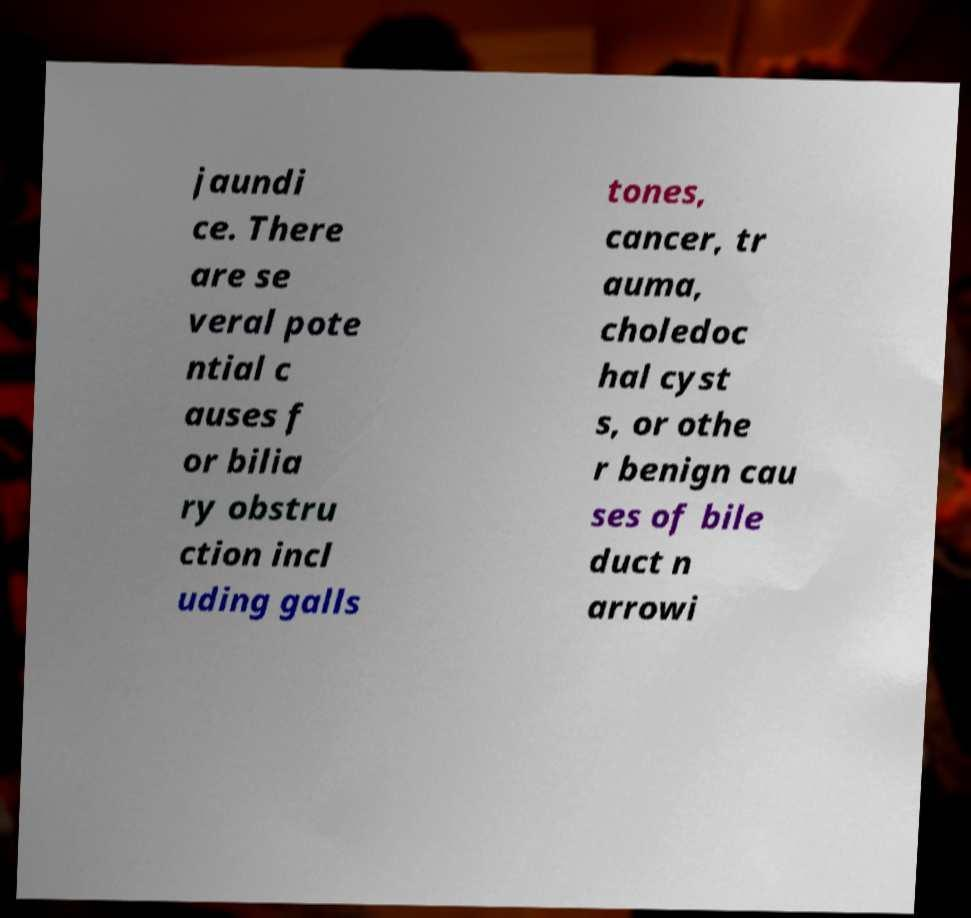Please read and relay the text visible in this image. What does it say? jaundi ce. There are se veral pote ntial c auses f or bilia ry obstru ction incl uding galls tones, cancer, tr auma, choledoc hal cyst s, or othe r benign cau ses of bile duct n arrowi 